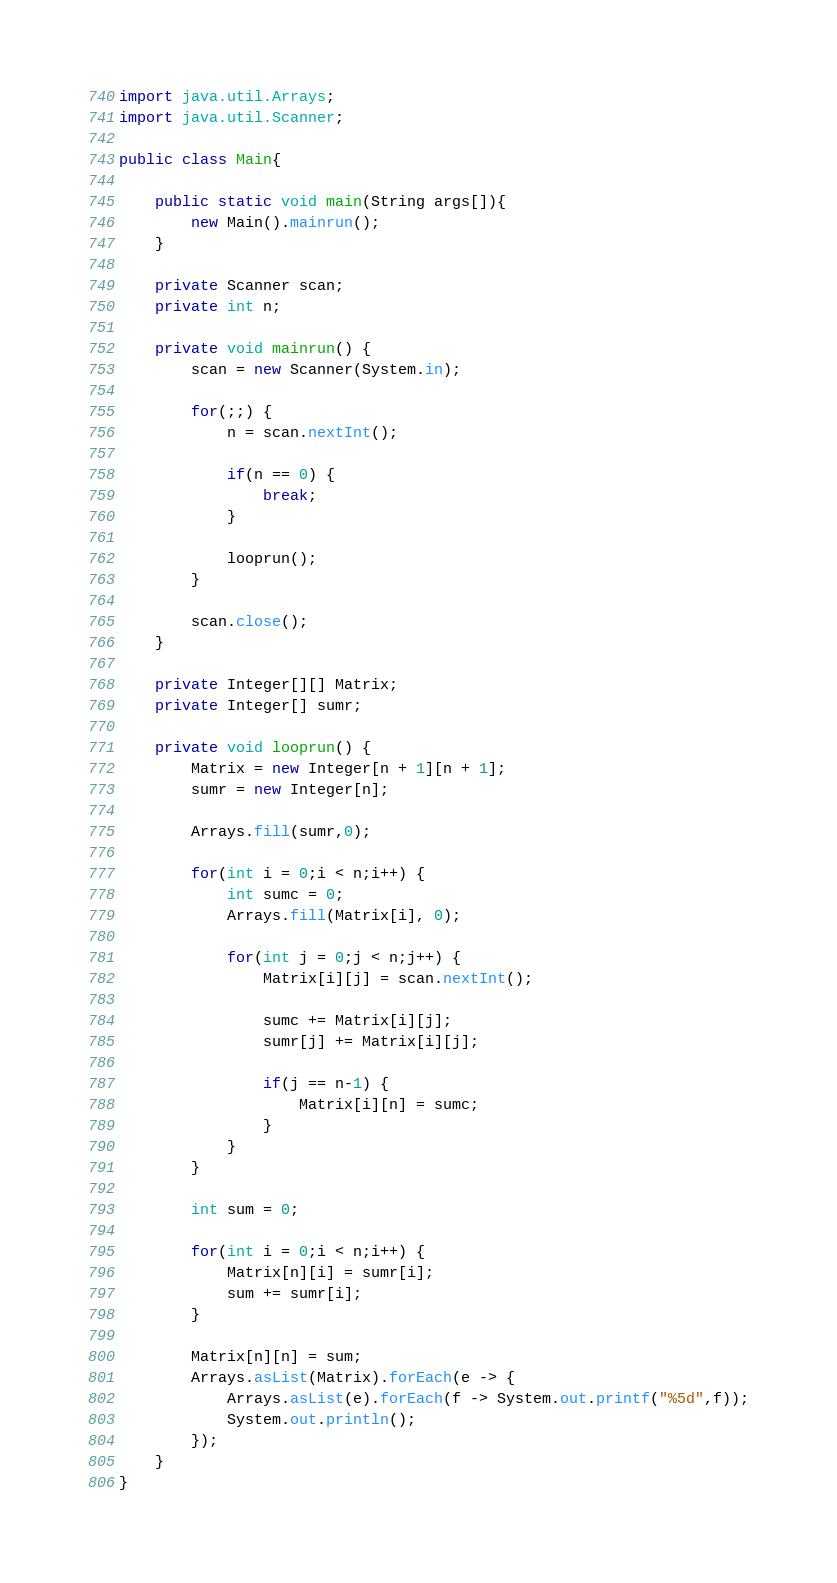<code> <loc_0><loc_0><loc_500><loc_500><_Java_>import java.util.Arrays;
import java.util.Scanner;

public class Main{

	public static void main(String args[]){
		new Main().mainrun();
	}

	private Scanner scan;
	private int n;

	private void mainrun() {
		scan = new Scanner(System.in);

		for(;;) {
			n = scan.nextInt();

			if(n == 0) {
				break;
			}

			looprun();
		}

		scan.close();
	}

	private Integer[][] Matrix;
	private Integer[] sumr;

	private void looprun() {
		Matrix = new Integer[n + 1][n + 1];
		sumr = new Integer[n];

		Arrays.fill(sumr,0);

		for(int i = 0;i < n;i++) {
			int sumc = 0;
			Arrays.fill(Matrix[i], 0);

			for(int j = 0;j < n;j++) {
				Matrix[i][j] = scan.nextInt();

				sumc += Matrix[i][j];
				sumr[j] += Matrix[i][j];

				if(j == n-1) {
					Matrix[i][n] = sumc;
				}
			}
		}

		int sum = 0;

		for(int i = 0;i < n;i++) {
			Matrix[n][i] = sumr[i];
			sum += sumr[i];
		}

		Matrix[n][n] = sum;
		Arrays.asList(Matrix).forEach(e -> {
			Arrays.asList(e).forEach(f -> System.out.printf("%5d",f));
			System.out.println();
		});
	}
}
</code> 